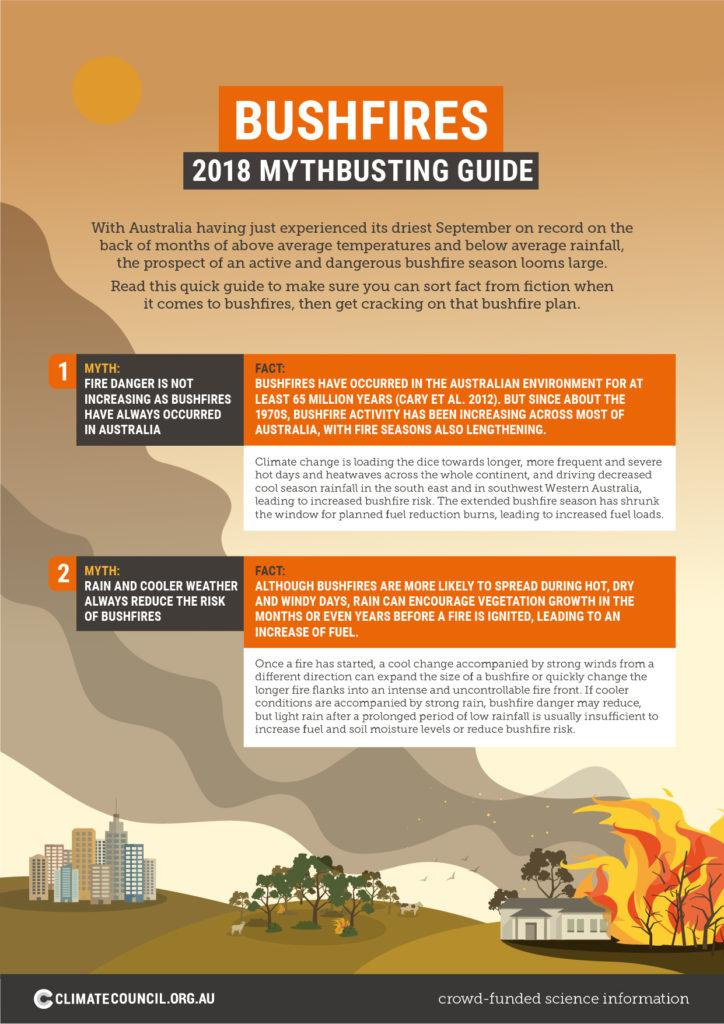Outline some significant characteristics in this image. The belief that rain and cooler weather always reduce the risk of bushfires is a myth. The increased frequency and severity of bushfires can be attributed to the buildup of fuel loads, which has been exacerbated by extended periods of dry weather and a changing climate. Climate change is causing an increase in heatwaves. 